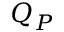Convert formula to latex. <formula><loc_0><loc_0><loc_500><loc_500>Q _ { P }</formula> 